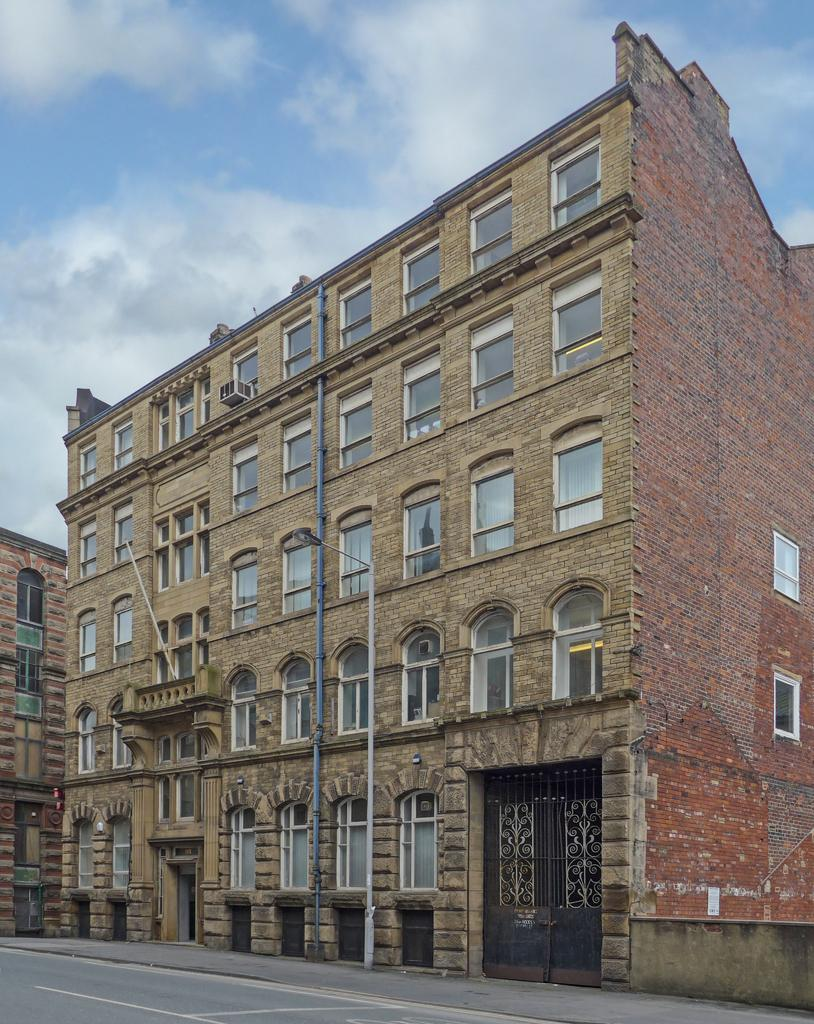What is the main structure in the center of the image? There is a building with windows and doors in the center of the image. What is located at the bottom of the image? There is a road at the bottom of the image. What can be seen at the top of the image? Sky is visible at the top of the image. How does the building form a melody in the image? The building does not form a melody in the image; it is a physical structure with windows and doors. 